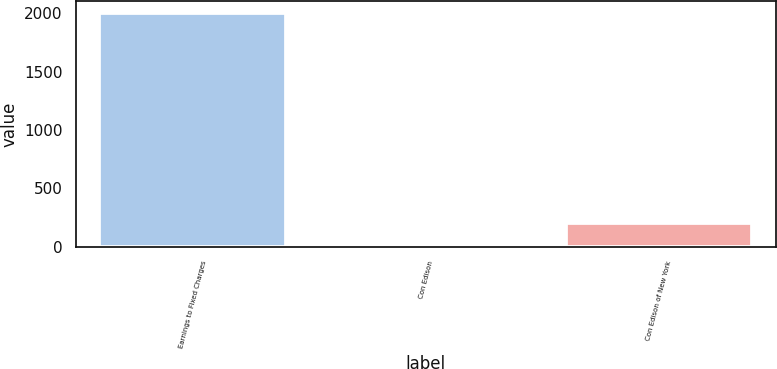Convert chart. <chart><loc_0><loc_0><loc_500><loc_500><bar_chart><fcel>Earnings to Fixed Charges<fcel>Con Edison<fcel>Con Edison of New York<nl><fcel>2004<fcel>2.6<fcel>202.74<nl></chart> 